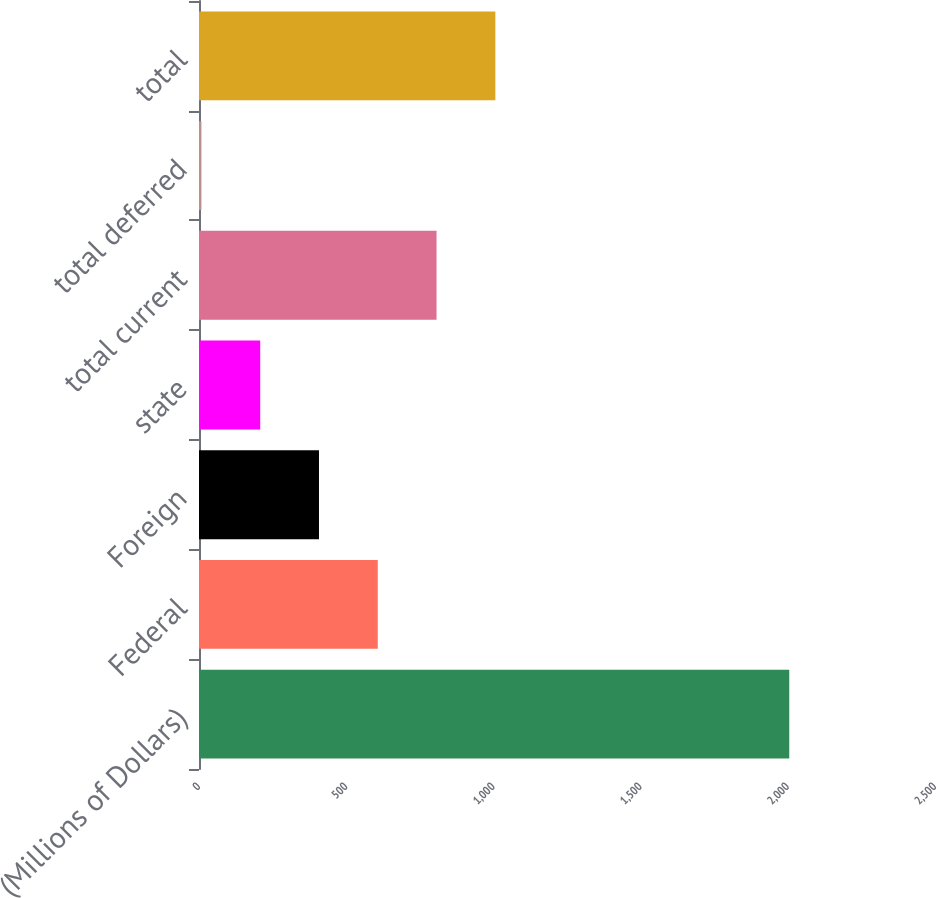<chart> <loc_0><loc_0><loc_500><loc_500><bar_chart><fcel>(Millions of Dollars)<fcel>Federal<fcel>Foreign<fcel>state<fcel>total current<fcel>total deferred<fcel>total<nl><fcel>2005<fcel>607.24<fcel>407.56<fcel>207.88<fcel>806.92<fcel>8.2<fcel>1006.6<nl></chart> 